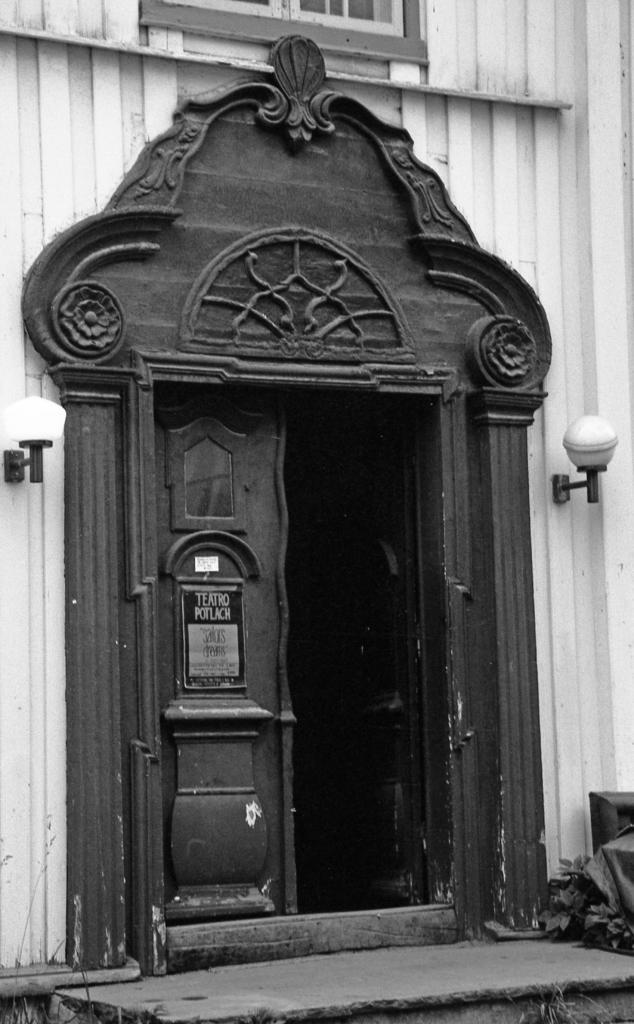Can you describe this image briefly? It is a black and white image. In this image we can see a building with the window, doors and also the lights. We can also see the plant and also the path. 